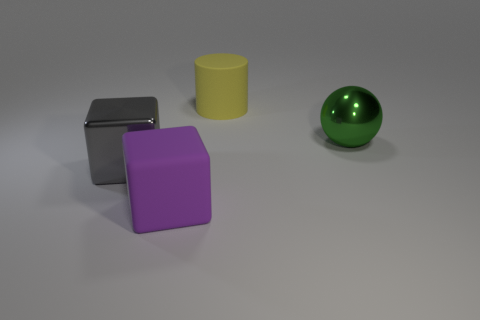What number of things are large objects that are to the right of the large yellow cylinder or tiny brown cubes?
Keep it short and to the point. 1. What is the size of the gray object that is made of the same material as the ball?
Make the answer very short. Large. Is the number of cylinders left of the gray block greater than the number of big cyan cylinders?
Provide a short and direct response. No. Do the large gray object and the matte object that is to the right of the big rubber block have the same shape?
Give a very brief answer. No. How many large things are either yellow cylinders or purple rubber blocks?
Make the answer very short. 2. What color is the object in front of the metallic object to the left of the cylinder?
Your answer should be compact. Purple. Do the large ball and the large gray block that is left of the yellow object have the same material?
Provide a succinct answer. Yes. What material is the thing that is right of the large cylinder?
Provide a succinct answer. Metal. Is the number of metallic cubes behind the ball the same as the number of purple things?
Offer a very short reply. No. Is there anything else that has the same size as the gray object?
Provide a short and direct response. Yes. 